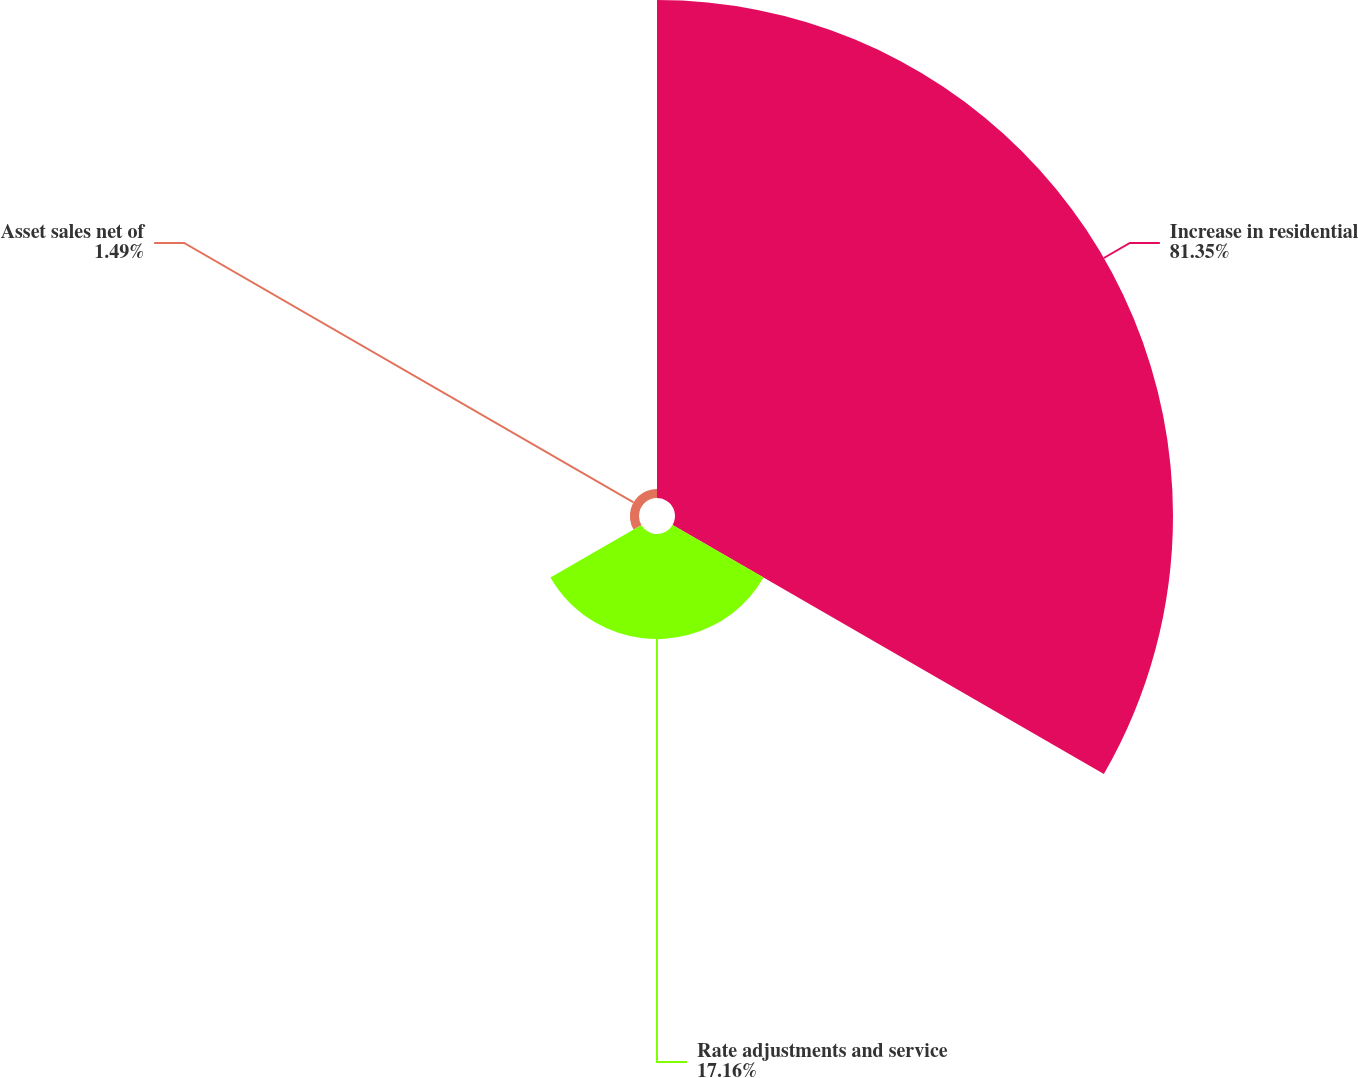Convert chart. <chart><loc_0><loc_0><loc_500><loc_500><pie_chart><fcel>Increase in residential<fcel>Rate adjustments and service<fcel>Asset sales net of<nl><fcel>81.34%<fcel>17.16%<fcel>1.49%<nl></chart> 